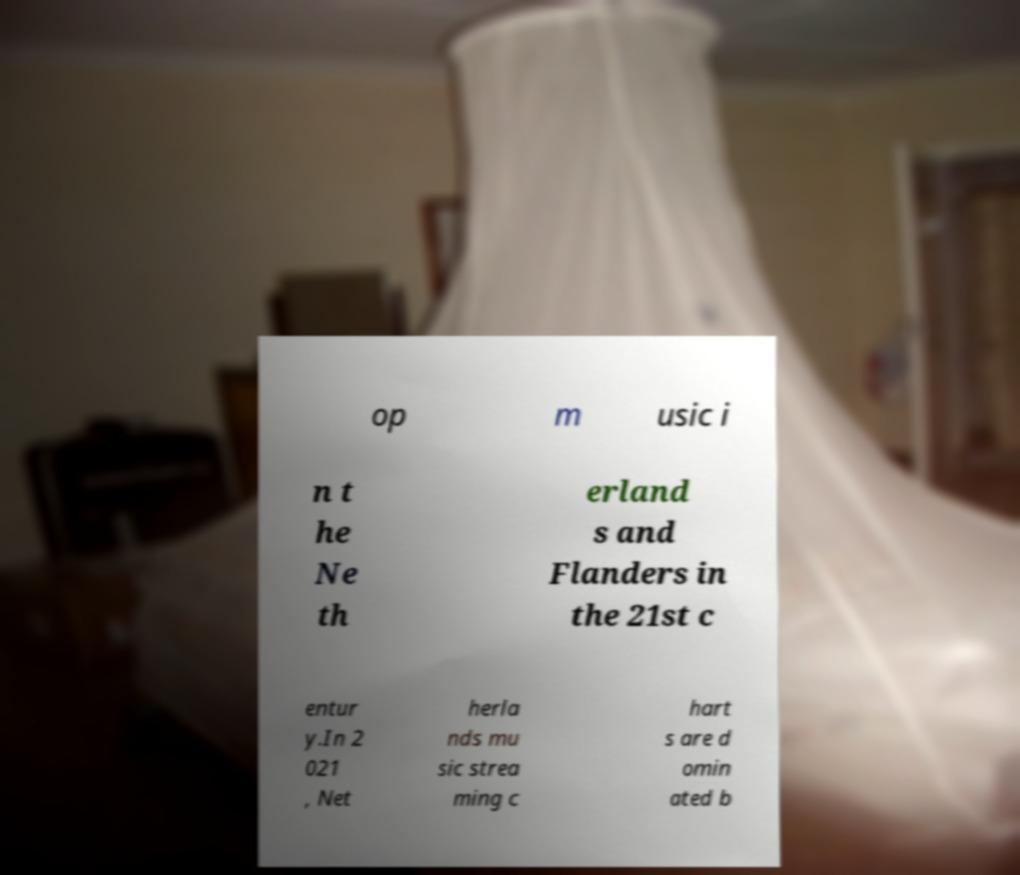Please identify and transcribe the text found in this image. op m usic i n t he Ne th erland s and Flanders in the 21st c entur y.In 2 021 , Net herla nds mu sic strea ming c hart s are d omin ated b 